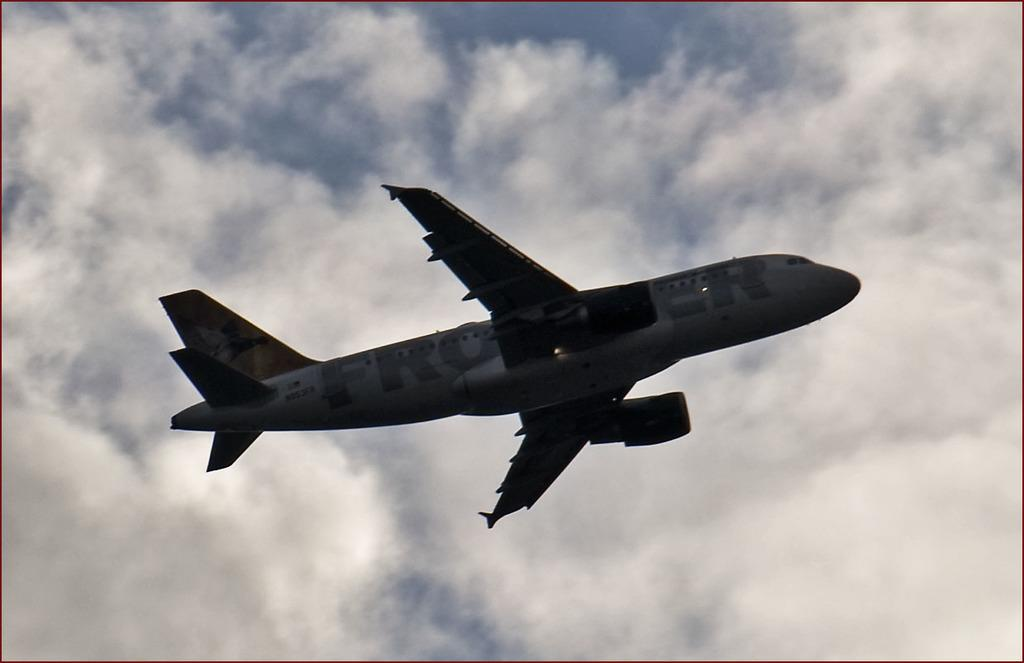<image>
Present a compact description of the photo's key features. A plane flying beneath the clouds with Frontier written on the side 